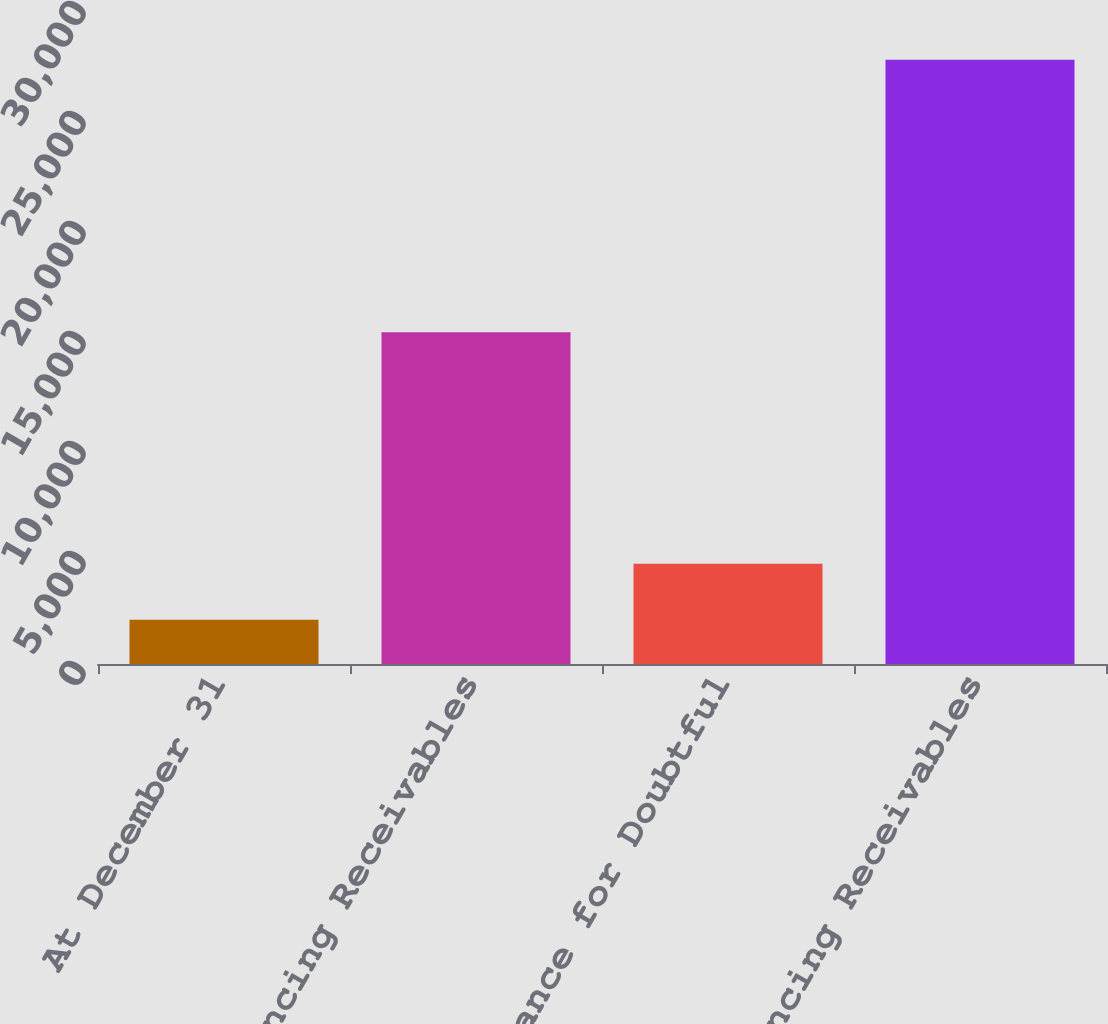Convert chart to OTSL. <chart><loc_0><loc_0><loc_500><loc_500><bar_chart><fcel>At December 31<fcel>Gross Financing Receivables<fcel>Allowance for Doubtful<fcel>Net Financing Receivables<nl><fcel>2015<fcel>15080<fcel>4560.1<fcel>27466<nl></chart> 